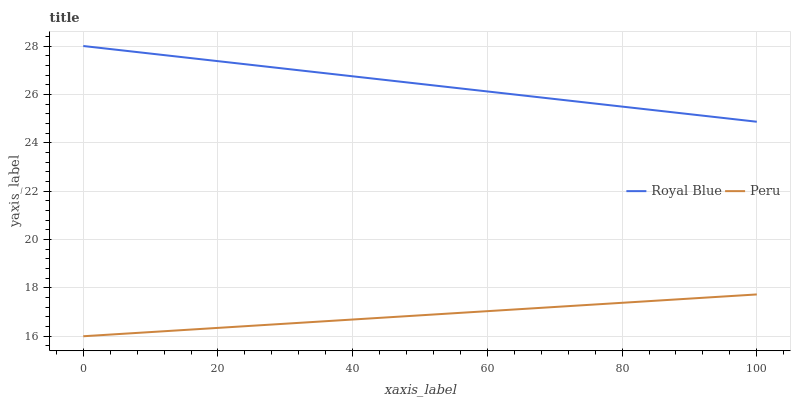Does Peru have the minimum area under the curve?
Answer yes or no. Yes. Does Royal Blue have the maximum area under the curve?
Answer yes or no. Yes. Does Peru have the maximum area under the curve?
Answer yes or no. No. Is Royal Blue the smoothest?
Answer yes or no. Yes. Is Peru the roughest?
Answer yes or no. Yes. Is Peru the smoothest?
Answer yes or no. No. Does Peru have the lowest value?
Answer yes or no. Yes. Does Royal Blue have the highest value?
Answer yes or no. Yes. Does Peru have the highest value?
Answer yes or no. No. Is Peru less than Royal Blue?
Answer yes or no. Yes. Is Royal Blue greater than Peru?
Answer yes or no. Yes. Does Peru intersect Royal Blue?
Answer yes or no. No. 